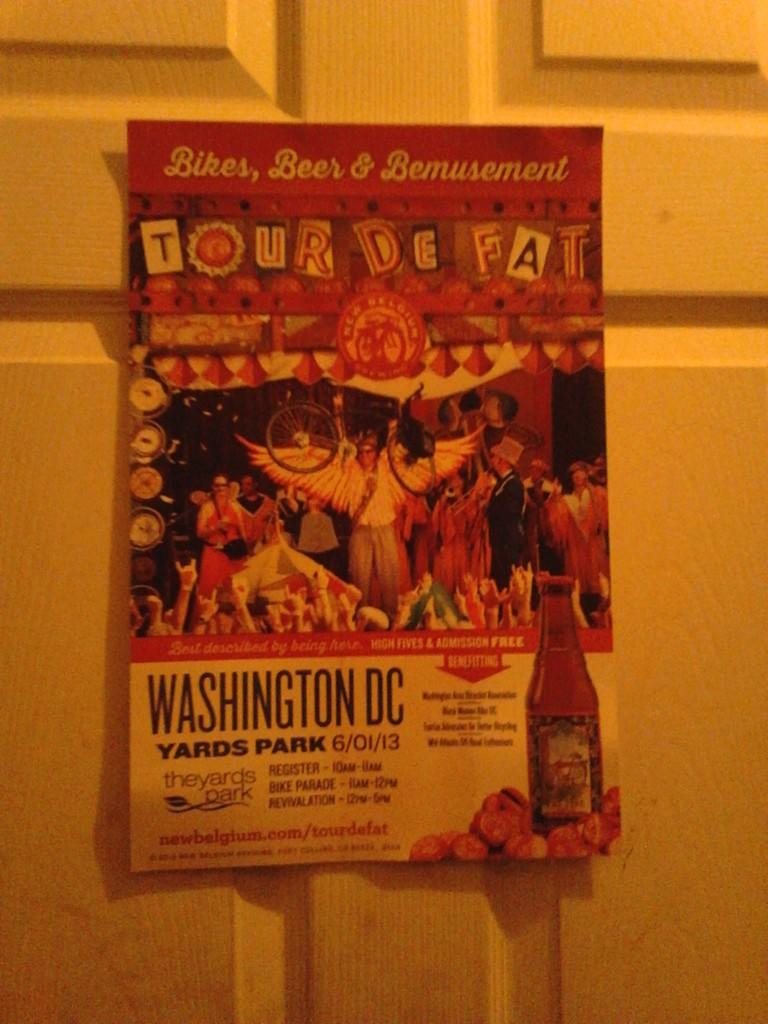<image>
Create a compact narrative representing the image presented. A poster for an event called "Tour de Fat" was held in Washington DC in 2013. 